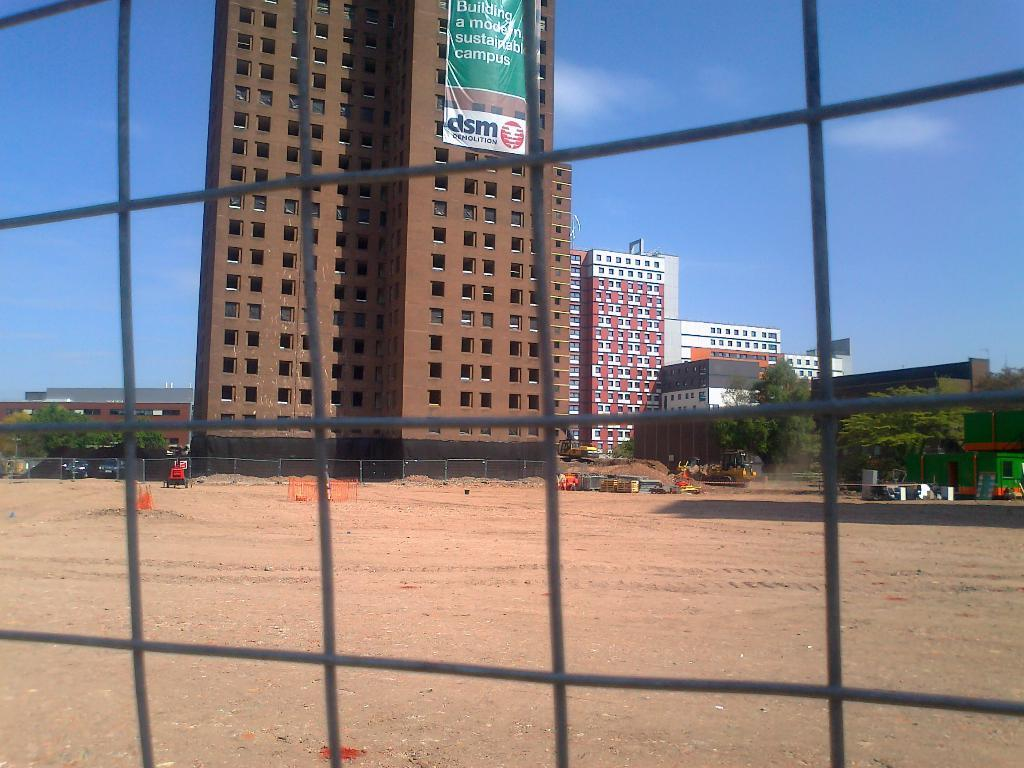What is located in the center of the image? There is a fence in the center of the image. What can be seen through the fence? The sky, clouds, buildings, a banner, trees, vehicles, and other objects are visible through the fence. What is the tendency of the suit to observe the objects through the fence? There is no suit or user mentioned in the image, and the image does not depict any observation or tendency. 